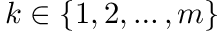Convert formula to latex. <formula><loc_0><loc_0><loc_500><loc_500>k \in \{ 1 , 2 , \dots , m \}</formula> 